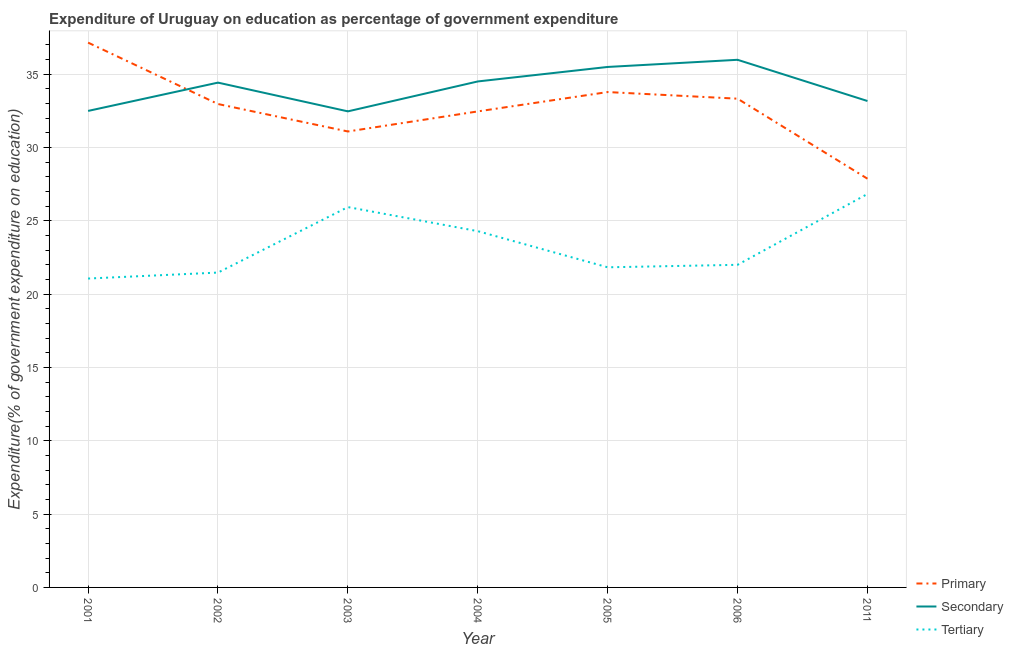How many different coloured lines are there?
Offer a very short reply. 3. Does the line corresponding to expenditure on primary education intersect with the line corresponding to expenditure on secondary education?
Provide a short and direct response. Yes. Is the number of lines equal to the number of legend labels?
Provide a short and direct response. Yes. What is the expenditure on tertiary education in 2002?
Keep it short and to the point. 21.47. Across all years, what is the maximum expenditure on secondary education?
Offer a very short reply. 35.98. Across all years, what is the minimum expenditure on tertiary education?
Your response must be concise. 21.07. In which year was the expenditure on secondary education minimum?
Keep it short and to the point. 2003. What is the total expenditure on secondary education in the graph?
Provide a short and direct response. 238.56. What is the difference between the expenditure on secondary education in 2002 and that in 2005?
Offer a very short reply. -1.07. What is the difference between the expenditure on tertiary education in 2004 and the expenditure on primary education in 2005?
Keep it short and to the point. -9.49. What is the average expenditure on primary education per year?
Offer a very short reply. 32.67. In the year 2003, what is the difference between the expenditure on tertiary education and expenditure on primary education?
Keep it short and to the point. -5.16. What is the ratio of the expenditure on tertiary education in 2004 to that in 2005?
Your answer should be compact. 1.11. Is the expenditure on primary education in 2003 less than that in 2004?
Provide a short and direct response. Yes. Is the difference between the expenditure on tertiary education in 2003 and 2006 greater than the difference between the expenditure on primary education in 2003 and 2006?
Give a very brief answer. Yes. What is the difference between the highest and the second highest expenditure on primary education?
Your answer should be very brief. 3.37. What is the difference between the highest and the lowest expenditure on tertiary education?
Give a very brief answer. 5.77. In how many years, is the expenditure on primary education greater than the average expenditure on primary education taken over all years?
Offer a terse response. 4. Is it the case that in every year, the sum of the expenditure on primary education and expenditure on secondary education is greater than the expenditure on tertiary education?
Ensure brevity in your answer.  Yes. Does the expenditure on primary education monotonically increase over the years?
Your answer should be very brief. No. Is the expenditure on secondary education strictly greater than the expenditure on tertiary education over the years?
Your answer should be compact. Yes. Is the expenditure on primary education strictly less than the expenditure on tertiary education over the years?
Make the answer very short. No. How many years are there in the graph?
Ensure brevity in your answer.  7. What is the difference between two consecutive major ticks on the Y-axis?
Make the answer very short. 5. Are the values on the major ticks of Y-axis written in scientific E-notation?
Offer a terse response. No. Where does the legend appear in the graph?
Provide a succinct answer. Bottom right. What is the title of the graph?
Offer a terse response. Expenditure of Uruguay on education as percentage of government expenditure. Does "Labor Market" appear as one of the legend labels in the graph?
Provide a succinct answer. No. What is the label or title of the X-axis?
Offer a terse response. Year. What is the label or title of the Y-axis?
Offer a terse response. Expenditure(% of government expenditure on education). What is the Expenditure(% of government expenditure on education) of Primary in 2001?
Ensure brevity in your answer.  37.16. What is the Expenditure(% of government expenditure on education) of Secondary in 2001?
Provide a short and direct response. 32.5. What is the Expenditure(% of government expenditure on education) of Tertiary in 2001?
Provide a succinct answer. 21.07. What is the Expenditure(% of government expenditure on education) of Primary in 2002?
Your response must be concise. 32.97. What is the Expenditure(% of government expenditure on education) of Secondary in 2002?
Offer a terse response. 34.43. What is the Expenditure(% of government expenditure on education) in Tertiary in 2002?
Ensure brevity in your answer.  21.47. What is the Expenditure(% of government expenditure on education) in Primary in 2003?
Offer a terse response. 31.1. What is the Expenditure(% of government expenditure on education) in Secondary in 2003?
Your answer should be very brief. 32.47. What is the Expenditure(% of government expenditure on education) in Tertiary in 2003?
Provide a short and direct response. 25.94. What is the Expenditure(% of government expenditure on education) in Primary in 2004?
Provide a succinct answer. 32.47. What is the Expenditure(% of government expenditure on education) in Secondary in 2004?
Your response must be concise. 34.51. What is the Expenditure(% of government expenditure on education) of Tertiary in 2004?
Make the answer very short. 24.3. What is the Expenditure(% of government expenditure on education) of Primary in 2005?
Make the answer very short. 33.78. What is the Expenditure(% of government expenditure on education) in Secondary in 2005?
Your answer should be very brief. 35.5. What is the Expenditure(% of government expenditure on education) in Tertiary in 2005?
Your answer should be very brief. 21.83. What is the Expenditure(% of government expenditure on education) in Primary in 2006?
Provide a short and direct response. 33.33. What is the Expenditure(% of government expenditure on education) in Secondary in 2006?
Provide a short and direct response. 35.98. What is the Expenditure(% of government expenditure on education) in Tertiary in 2006?
Ensure brevity in your answer.  22. What is the Expenditure(% of government expenditure on education) in Primary in 2011?
Offer a very short reply. 27.88. What is the Expenditure(% of government expenditure on education) in Secondary in 2011?
Offer a very short reply. 33.17. What is the Expenditure(% of government expenditure on education) in Tertiary in 2011?
Offer a terse response. 26.83. Across all years, what is the maximum Expenditure(% of government expenditure on education) in Primary?
Give a very brief answer. 37.16. Across all years, what is the maximum Expenditure(% of government expenditure on education) in Secondary?
Keep it short and to the point. 35.98. Across all years, what is the maximum Expenditure(% of government expenditure on education) in Tertiary?
Offer a terse response. 26.83. Across all years, what is the minimum Expenditure(% of government expenditure on education) of Primary?
Ensure brevity in your answer.  27.88. Across all years, what is the minimum Expenditure(% of government expenditure on education) in Secondary?
Your answer should be compact. 32.47. Across all years, what is the minimum Expenditure(% of government expenditure on education) in Tertiary?
Offer a terse response. 21.07. What is the total Expenditure(% of government expenditure on education) of Primary in the graph?
Ensure brevity in your answer.  228.68. What is the total Expenditure(% of government expenditure on education) of Secondary in the graph?
Your response must be concise. 238.56. What is the total Expenditure(% of government expenditure on education) of Tertiary in the graph?
Keep it short and to the point. 163.45. What is the difference between the Expenditure(% of government expenditure on education) of Primary in 2001 and that in 2002?
Keep it short and to the point. 4.19. What is the difference between the Expenditure(% of government expenditure on education) of Secondary in 2001 and that in 2002?
Your response must be concise. -1.93. What is the difference between the Expenditure(% of government expenditure on education) of Tertiary in 2001 and that in 2002?
Your response must be concise. -0.41. What is the difference between the Expenditure(% of government expenditure on education) in Primary in 2001 and that in 2003?
Your answer should be very brief. 6.06. What is the difference between the Expenditure(% of government expenditure on education) of Secondary in 2001 and that in 2003?
Your response must be concise. 0.03. What is the difference between the Expenditure(% of government expenditure on education) of Tertiary in 2001 and that in 2003?
Your answer should be compact. -4.87. What is the difference between the Expenditure(% of government expenditure on education) of Primary in 2001 and that in 2004?
Give a very brief answer. 4.69. What is the difference between the Expenditure(% of government expenditure on education) in Secondary in 2001 and that in 2004?
Your answer should be compact. -2.01. What is the difference between the Expenditure(% of government expenditure on education) of Tertiary in 2001 and that in 2004?
Ensure brevity in your answer.  -3.23. What is the difference between the Expenditure(% of government expenditure on education) of Primary in 2001 and that in 2005?
Your answer should be compact. 3.37. What is the difference between the Expenditure(% of government expenditure on education) of Secondary in 2001 and that in 2005?
Your answer should be compact. -3. What is the difference between the Expenditure(% of government expenditure on education) in Tertiary in 2001 and that in 2005?
Provide a succinct answer. -0.77. What is the difference between the Expenditure(% of government expenditure on education) of Primary in 2001 and that in 2006?
Offer a very short reply. 3.82. What is the difference between the Expenditure(% of government expenditure on education) in Secondary in 2001 and that in 2006?
Provide a short and direct response. -3.49. What is the difference between the Expenditure(% of government expenditure on education) of Tertiary in 2001 and that in 2006?
Your answer should be compact. -0.94. What is the difference between the Expenditure(% of government expenditure on education) of Primary in 2001 and that in 2011?
Provide a succinct answer. 9.28. What is the difference between the Expenditure(% of government expenditure on education) in Secondary in 2001 and that in 2011?
Make the answer very short. -0.68. What is the difference between the Expenditure(% of government expenditure on education) of Tertiary in 2001 and that in 2011?
Provide a short and direct response. -5.77. What is the difference between the Expenditure(% of government expenditure on education) in Primary in 2002 and that in 2003?
Offer a very short reply. 1.87. What is the difference between the Expenditure(% of government expenditure on education) in Secondary in 2002 and that in 2003?
Provide a succinct answer. 1.96. What is the difference between the Expenditure(% of government expenditure on education) in Tertiary in 2002 and that in 2003?
Provide a succinct answer. -4.47. What is the difference between the Expenditure(% of government expenditure on education) of Primary in 2002 and that in 2004?
Provide a succinct answer. 0.5. What is the difference between the Expenditure(% of government expenditure on education) in Secondary in 2002 and that in 2004?
Ensure brevity in your answer.  -0.08. What is the difference between the Expenditure(% of government expenditure on education) in Tertiary in 2002 and that in 2004?
Your answer should be compact. -2.82. What is the difference between the Expenditure(% of government expenditure on education) in Primary in 2002 and that in 2005?
Offer a terse response. -0.82. What is the difference between the Expenditure(% of government expenditure on education) in Secondary in 2002 and that in 2005?
Your answer should be very brief. -1.07. What is the difference between the Expenditure(% of government expenditure on education) of Tertiary in 2002 and that in 2005?
Give a very brief answer. -0.36. What is the difference between the Expenditure(% of government expenditure on education) in Primary in 2002 and that in 2006?
Provide a succinct answer. -0.36. What is the difference between the Expenditure(% of government expenditure on education) of Secondary in 2002 and that in 2006?
Provide a succinct answer. -1.56. What is the difference between the Expenditure(% of government expenditure on education) in Tertiary in 2002 and that in 2006?
Your response must be concise. -0.53. What is the difference between the Expenditure(% of government expenditure on education) in Primary in 2002 and that in 2011?
Make the answer very short. 5.09. What is the difference between the Expenditure(% of government expenditure on education) in Secondary in 2002 and that in 2011?
Offer a very short reply. 1.25. What is the difference between the Expenditure(% of government expenditure on education) in Tertiary in 2002 and that in 2011?
Offer a very short reply. -5.36. What is the difference between the Expenditure(% of government expenditure on education) in Primary in 2003 and that in 2004?
Provide a succinct answer. -1.37. What is the difference between the Expenditure(% of government expenditure on education) of Secondary in 2003 and that in 2004?
Keep it short and to the point. -2.04. What is the difference between the Expenditure(% of government expenditure on education) in Tertiary in 2003 and that in 2004?
Keep it short and to the point. 1.64. What is the difference between the Expenditure(% of government expenditure on education) of Primary in 2003 and that in 2005?
Offer a very short reply. -2.69. What is the difference between the Expenditure(% of government expenditure on education) of Secondary in 2003 and that in 2005?
Your answer should be very brief. -3.03. What is the difference between the Expenditure(% of government expenditure on education) of Tertiary in 2003 and that in 2005?
Your answer should be compact. 4.11. What is the difference between the Expenditure(% of government expenditure on education) in Primary in 2003 and that in 2006?
Keep it short and to the point. -2.24. What is the difference between the Expenditure(% of government expenditure on education) of Secondary in 2003 and that in 2006?
Offer a very short reply. -3.52. What is the difference between the Expenditure(% of government expenditure on education) in Tertiary in 2003 and that in 2006?
Provide a succinct answer. 3.94. What is the difference between the Expenditure(% of government expenditure on education) in Primary in 2003 and that in 2011?
Make the answer very short. 3.22. What is the difference between the Expenditure(% of government expenditure on education) in Secondary in 2003 and that in 2011?
Your answer should be very brief. -0.71. What is the difference between the Expenditure(% of government expenditure on education) in Tertiary in 2003 and that in 2011?
Provide a short and direct response. -0.89. What is the difference between the Expenditure(% of government expenditure on education) in Primary in 2004 and that in 2005?
Provide a short and direct response. -1.32. What is the difference between the Expenditure(% of government expenditure on education) in Secondary in 2004 and that in 2005?
Provide a succinct answer. -0.99. What is the difference between the Expenditure(% of government expenditure on education) of Tertiary in 2004 and that in 2005?
Your response must be concise. 2.47. What is the difference between the Expenditure(% of government expenditure on education) of Primary in 2004 and that in 2006?
Provide a short and direct response. -0.87. What is the difference between the Expenditure(% of government expenditure on education) in Secondary in 2004 and that in 2006?
Your response must be concise. -1.48. What is the difference between the Expenditure(% of government expenditure on education) in Tertiary in 2004 and that in 2006?
Give a very brief answer. 2.3. What is the difference between the Expenditure(% of government expenditure on education) in Primary in 2004 and that in 2011?
Your response must be concise. 4.59. What is the difference between the Expenditure(% of government expenditure on education) of Secondary in 2004 and that in 2011?
Your response must be concise. 1.33. What is the difference between the Expenditure(% of government expenditure on education) in Tertiary in 2004 and that in 2011?
Keep it short and to the point. -2.54. What is the difference between the Expenditure(% of government expenditure on education) in Primary in 2005 and that in 2006?
Your response must be concise. 0.45. What is the difference between the Expenditure(% of government expenditure on education) of Secondary in 2005 and that in 2006?
Your answer should be compact. -0.49. What is the difference between the Expenditure(% of government expenditure on education) in Tertiary in 2005 and that in 2006?
Keep it short and to the point. -0.17. What is the difference between the Expenditure(% of government expenditure on education) in Primary in 2005 and that in 2011?
Keep it short and to the point. 5.91. What is the difference between the Expenditure(% of government expenditure on education) of Secondary in 2005 and that in 2011?
Offer a very short reply. 2.32. What is the difference between the Expenditure(% of government expenditure on education) in Tertiary in 2005 and that in 2011?
Provide a succinct answer. -5. What is the difference between the Expenditure(% of government expenditure on education) of Primary in 2006 and that in 2011?
Your response must be concise. 5.46. What is the difference between the Expenditure(% of government expenditure on education) of Secondary in 2006 and that in 2011?
Your answer should be compact. 2.81. What is the difference between the Expenditure(% of government expenditure on education) in Tertiary in 2006 and that in 2011?
Offer a very short reply. -4.83. What is the difference between the Expenditure(% of government expenditure on education) of Primary in 2001 and the Expenditure(% of government expenditure on education) of Secondary in 2002?
Offer a terse response. 2.73. What is the difference between the Expenditure(% of government expenditure on education) of Primary in 2001 and the Expenditure(% of government expenditure on education) of Tertiary in 2002?
Your answer should be compact. 15.68. What is the difference between the Expenditure(% of government expenditure on education) of Secondary in 2001 and the Expenditure(% of government expenditure on education) of Tertiary in 2002?
Keep it short and to the point. 11.02. What is the difference between the Expenditure(% of government expenditure on education) of Primary in 2001 and the Expenditure(% of government expenditure on education) of Secondary in 2003?
Ensure brevity in your answer.  4.69. What is the difference between the Expenditure(% of government expenditure on education) in Primary in 2001 and the Expenditure(% of government expenditure on education) in Tertiary in 2003?
Provide a succinct answer. 11.22. What is the difference between the Expenditure(% of government expenditure on education) in Secondary in 2001 and the Expenditure(% of government expenditure on education) in Tertiary in 2003?
Provide a succinct answer. 6.56. What is the difference between the Expenditure(% of government expenditure on education) in Primary in 2001 and the Expenditure(% of government expenditure on education) in Secondary in 2004?
Your response must be concise. 2.65. What is the difference between the Expenditure(% of government expenditure on education) in Primary in 2001 and the Expenditure(% of government expenditure on education) in Tertiary in 2004?
Provide a short and direct response. 12.86. What is the difference between the Expenditure(% of government expenditure on education) in Secondary in 2001 and the Expenditure(% of government expenditure on education) in Tertiary in 2004?
Offer a terse response. 8.2. What is the difference between the Expenditure(% of government expenditure on education) in Primary in 2001 and the Expenditure(% of government expenditure on education) in Secondary in 2005?
Your response must be concise. 1.66. What is the difference between the Expenditure(% of government expenditure on education) in Primary in 2001 and the Expenditure(% of government expenditure on education) in Tertiary in 2005?
Provide a succinct answer. 15.32. What is the difference between the Expenditure(% of government expenditure on education) of Secondary in 2001 and the Expenditure(% of government expenditure on education) of Tertiary in 2005?
Your answer should be very brief. 10.67. What is the difference between the Expenditure(% of government expenditure on education) of Primary in 2001 and the Expenditure(% of government expenditure on education) of Secondary in 2006?
Offer a terse response. 1.17. What is the difference between the Expenditure(% of government expenditure on education) of Primary in 2001 and the Expenditure(% of government expenditure on education) of Tertiary in 2006?
Give a very brief answer. 15.15. What is the difference between the Expenditure(% of government expenditure on education) in Secondary in 2001 and the Expenditure(% of government expenditure on education) in Tertiary in 2006?
Give a very brief answer. 10.5. What is the difference between the Expenditure(% of government expenditure on education) in Primary in 2001 and the Expenditure(% of government expenditure on education) in Secondary in 2011?
Offer a terse response. 3.98. What is the difference between the Expenditure(% of government expenditure on education) of Primary in 2001 and the Expenditure(% of government expenditure on education) of Tertiary in 2011?
Offer a terse response. 10.32. What is the difference between the Expenditure(% of government expenditure on education) in Secondary in 2001 and the Expenditure(% of government expenditure on education) in Tertiary in 2011?
Give a very brief answer. 5.66. What is the difference between the Expenditure(% of government expenditure on education) in Primary in 2002 and the Expenditure(% of government expenditure on education) in Secondary in 2003?
Provide a succinct answer. 0.5. What is the difference between the Expenditure(% of government expenditure on education) in Primary in 2002 and the Expenditure(% of government expenditure on education) in Tertiary in 2003?
Make the answer very short. 7.03. What is the difference between the Expenditure(% of government expenditure on education) of Secondary in 2002 and the Expenditure(% of government expenditure on education) of Tertiary in 2003?
Your response must be concise. 8.49. What is the difference between the Expenditure(% of government expenditure on education) of Primary in 2002 and the Expenditure(% of government expenditure on education) of Secondary in 2004?
Offer a very short reply. -1.54. What is the difference between the Expenditure(% of government expenditure on education) of Primary in 2002 and the Expenditure(% of government expenditure on education) of Tertiary in 2004?
Offer a terse response. 8.67. What is the difference between the Expenditure(% of government expenditure on education) in Secondary in 2002 and the Expenditure(% of government expenditure on education) in Tertiary in 2004?
Offer a terse response. 10.13. What is the difference between the Expenditure(% of government expenditure on education) in Primary in 2002 and the Expenditure(% of government expenditure on education) in Secondary in 2005?
Provide a succinct answer. -2.53. What is the difference between the Expenditure(% of government expenditure on education) in Primary in 2002 and the Expenditure(% of government expenditure on education) in Tertiary in 2005?
Offer a terse response. 11.14. What is the difference between the Expenditure(% of government expenditure on education) of Secondary in 2002 and the Expenditure(% of government expenditure on education) of Tertiary in 2005?
Your answer should be compact. 12.6. What is the difference between the Expenditure(% of government expenditure on education) of Primary in 2002 and the Expenditure(% of government expenditure on education) of Secondary in 2006?
Provide a succinct answer. -3.02. What is the difference between the Expenditure(% of government expenditure on education) in Primary in 2002 and the Expenditure(% of government expenditure on education) in Tertiary in 2006?
Make the answer very short. 10.97. What is the difference between the Expenditure(% of government expenditure on education) of Secondary in 2002 and the Expenditure(% of government expenditure on education) of Tertiary in 2006?
Your answer should be compact. 12.43. What is the difference between the Expenditure(% of government expenditure on education) in Primary in 2002 and the Expenditure(% of government expenditure on education) in Secondary in 2011?
Make the answer very short. -0.21. What is the difference between the Expenditure(% of government expenditure on education) of Primary in 2002 and the Expenditure(% of government expenditure on education) of Tertiary in 2011?
Offer a very short reply. 6.14. What is the difference between the Expenditure(% of government expenditure on education) of Secondary in 2002 and the Expenditure(% of government expenditure on education) of Tertiary in 2011?
Give a very brief answer. 7.6. What is the difference between the Expenditure(% of government expenditure on education) of Primary in 2003 and the Expenditure(% of government expenditure on education) of Secondary in 2004?
Your response must be concise. -3.41. What is the difference between the Expenditure(% of government expenditure on education) of Primary in 2003 and the Expenditure(% of government expenditure on education) of Tertiary in 2004?
Your response must be concise. 6.8. What is the difference between the Expenditure(% of government expenditure on education) in Secondary in 2003 and the Expenditure(% of government expenditure on education) in Tertiary in 2004?
Ensure brevity in your answer.  8.17. What is the difference between the Expenditure(% of government expenditure on education) of Primary in 2003 and the Expenditure(% of government expenditure on education) of Secondary in 2005?
Provide a short and direct response. -4.4. What is the difference between the Expenditure(% of government expenditure on education) of Primary in 2003 and the Expenditure(% of government expenditure on education) of Tertiary in 2005?
Provide a short and direct response. 9.26. What is the difference between the Expenditure(% of government expenditure on education) in Secondary in 2003 and the Expenditure(% of government expenditure on education) in Tertiary in 2005?
Provide a short and direct response. 10.64. What is the difference between the Expenditure(% of government expenditure on education) in Primary in 2003 and the Expenditure(% of government expenditure on education) in Secondary in 2006?
Give a very brief answer. -4.89. What is the difference between the Expenditure(% of government expenditure on education) in Primary in 2003 and the Expenditure(% of government expenditure on education) in Tertiary in 2006?
Your answer should be very brief. 9.09. What is the difference between the Expenditure(% of government expenditure on education) in Secondary in 2003 and the Expenditure(% of government expenditure on education) in Tertiary in 2006?
Give a very brief answer. 10.47. What is the difference between the Expenditure(% of government expenditure on education) in Primary in 2003 and the Expenditure(% of government expenditure on education) in Secondary in 2011?
Offer a very short reply. -2.08. What is the difference between the Expenditure(% of government expenditure on education) of Primary in 2003 and the Expenditure(% of government expenditure on education) of Tertiary in 2011?
Offer a terse response. 4.26. What is the difference between the Expenditure(% of government expenditure on education) in Secondary in 2003 and the Expenditure(% of government expenditure on education) in Tertiary in 2011?
Offer a terse response. 5.63. What is the difference between the Expenditure(% of government expenditure on education) of Primary in 2004 and the Expenditure(% of government expenditure on education) of Secondary in 2005?
Offer a very short reply. -3.03. What is the difference between the Expenditure(% of government expenditure on education) in Primary in 2004 and the Expenditure(% of government expenditure on education) in Tertiary in 2005?
Keep it short and to the point. 10.63. What is the difference between the Expenditure(% of government expenditure on education) in Secondary in 2004 and the Expenditure(% of government expenditure on education) in Tertiary in 2005?
Provide a succinct answer. 12.68. What is the difference between the Expenditure(% of government expenditure on education) of Primary in 2004 and the Expenditure(% of government expenditure on education) of Secondary in 2006?
Give a very brief answer. -3.52. What is the difference between the Expenditure(% of government expenditure on education) in Primary in 2004 and the Expenditure(% of government expenditure on education) in Tertiary in 2006?
Provide a succinct answer. 10.46. What is the difference between the Expenditure(% of government expenditure on education) in Secondary in 2004 and the Expenditure(% of government expenditure on education) in Tertiary in 2006?
Provide a short and direct response. 12.51. What is the difference between the Expenditure(% of government expenditure on education) in Primary in 2004 and the Expenditure(% of government expenditure on education) in Secondary in 2011?
Offer a terse response. -0.71. What is the difference between the Expenditure(% of government expenditure on education) in Primary in 2004 and the Expenditure(% of government expenditure on education) in Tertiary in 2011?
Keep it short and to the point. 5.63. What is the difference between the Expenditure(% of government expenditure on education) in Secondary in 2004 and the Expenditure(% of government expenditure on education) in Tertiary in 2011?
Keep it short and to the point. 7.67. What is the difference between the Expenditure(% of government expenditure on education) in Primary in 2005 and the Expenditure(% of government expenditure on education) in Secondary in 2006?
Make the answer very short. -2.2. What is the difference between the Expenditure(% of government expenditure on education) in Primary in 2005 and the Expenditure(% of government expenditure on education) in Tertiary in 2006?
Your response must be concise. 11.78. What is the difference between the Expenditure(% of government expenditure on education) in Secondary in 2005 and the Expenditure(% of government expenditure on education) in Tertiary in 2006?
Your answer should be compact. 13.49. What is the difference between the Expenditure(% of government expenditure on education) in Primary in 2005 and the Expenditure(% of government expenditure on education) in Secondary in 2011?
Give a very brief answer. 0.61. What is the difference between the Expenditure(% of government expenditure on education) of Primary in 2005 and the Expenditure(% of government expenditure on education) of Tertiary in 2011?
Your response must be concise. 6.95. What is the difference between the Expenditure(% of government expenditure on education) in Secondary in 2005 and the Expenditure(% of government expenditure on education) in Tertiary in 2011?
Your answer should be compact. 8.66. What is the difference between the Expenditure(% of government expenditure on education) in Primary in 2006 and the Expenditure(% of government expenditure on education) in Secondary in 2011?
Provide a short and direct response. 0.16. What is the difference between the Expenditure(% of government expenditure on education) of Primary in 2006 and the Expenditure(% of government expenditure on education) of Tertiary in 2011?
Provide a succinct answer. 6.5. What is the difference between the Expenditure(% of government expenditure on education) of Secondary in 2006 and the Expenditure(% of government expenditure on education) of Tertiary in 2011?
Your answer should be compact. 9.15. What is the average Expenditure(% of government expenditure on education) of Primary per year?
Provide a short and direct response. 32.67. What is the average Expenditure(% of government expenditure on education) of Secondary per year?
Offer a very short reply. 34.08. What is the average Expenditure(% of government expenditure on education) in Tertiary per year?
Offer a very short reply. 23.35. In the year 2001, what is the difference between the Expenditure(% of government expenditure on education) of Primary and Expenditure(% of government expenditure on education) of Secondary?
Keep it short and to the point. 4.66. In the year 2001, what is the difference between the Expenditure(% of government expenditure on education) of Primary and Expenditure(% of government expenditure on education) of Tertiary?
Offer a very short reply. 16.09. In the year 2001, what is the difference between the Expenditure(% of government expenditure on education) of Secondary and Expenditure(% of government expenditure on education) of Tertiary?
Your answer should be very brief. 11.43. In the year 2002, what is the difference between the Expenditure(% of government expenditure on education) in Primary and Expenditure(% of government expenditure on education) in Secondary?
Keep it short and to the point. -1.46. In the year 2002, what is the difference between the Expenditure(% of government expenditure on education) of Primary and Expenditure(% of government expenditure on education) of Tertiary?
Offer a very short reply. 11.5. In the year 2002, what is the difference between the Expenditure(% of government expenditure on education) in Secondary and Expenditure(% of government expenditure on education) in Tertiary?
Keep it short and to the point. 12.96. In the year 2003, what is the difference between the Expenditure(% of government expenditure on education) of Primary and Expenditure(% of government expenditure on education) of Secondary?
Provide a succinct answer. -1.37. In the year 2003, what is the difference between the Expenditure(% of government expenditure on education) of Primary and Expenditure(% of government expenditure on education) of Tertiary?
Make the answer very short. 5.16. In the year 2003, what is the difference between the Expenditure(% of government expenditure on education) of Secondary and Expenditure(% of government expenditure on education) of Tertiary?
Your answer should be very brief. 6.53. In the year 2004, what is the difference between the Expenditure(% of government expenditure on education) of Primary and Expenditure(% of government expenditure on education) of Secondary?
Offer a terse response. -2.04. In the year 2004, what is the difference between the Expenditure(% of government expenditure on education) in Primary and Expenditure(% of government expenditure on education) in Tertiary?
Give a very brief answer. 8.17. In the year 2004, what is the difference between the Expenditure(% of government expenditure on education) of Secondary and Expenditure(% of government expenditure on education) of Tertiary?
Offer a terse response. 10.21. In the year 2005, what is the difference between the Expenditure(% of government expenditure on education) of Primary and Expenditure(% of government expenditure on education) of Secondary?
Your answer should be very brief. -1.71. In the year 2005, what is the difference between the Expenditure(% of government expenditure on education) in Primary and Expenditure(% of government expenditure on education) in Tertiary?
Offer a very short reply. 11.95. In the year 2005, what is the difference between the Expenditure(% of government expenditure on education) in Secondary and Expenditure(% of government expenditure on education) in Tertiary?
Your answer should be very brief. 13.66. In the year 2006, what is the difference between the Expenditure(% of government expenditure on education) of Primary and Expenditure(% of government expenditure on education) of Secondary?
Your response must be concise. -2.65. In the year 2006, what is the difference between the Expenditure(% of government expenditure on education) in Primary and Expenditure(% of government expenditure on education) in Tertiary?
Make the answer very short. 11.33. In the year 2006, what is the difference between the Expenditure(% of government expenditure on education) in Secondary and Expenditure(% of government expenditure on education) in Tertiary?
Keep it short and to the point. 13.98. In the year 2011, what is the difference between the Expenditure(% of government expenditure on education) of Primary and Expenditure(% of government expenditure on education) of Secondary?
Ensure brevity in your answer.  -5.3. In the year 2011, what is the difference between the Expenditure(% of government expenditure on education) of Primary and Expenditure(% of government expenditure on education) of Tertiary?
Make the answer very short. 1.04. In the year 2011, what is the difference between the Expenditure(% of government expenditure on education) of Secondary and Expenditure(% of government expenditure on education) of Tertiary?
Your answer should be very brief. 6.34. What is the ratio of the Expenditure(% of government expenditure on education) of Primary in 2001 to that in 2002?
Offer a terse response. 1.13. What is the ratio of the Expenditure(% of government expenditure on education) in Secondary in 2001 to that in 2002?
Offer a terse response. 0.94. What is the ratio of the Expenditure(% of government expenditure on education) of Primary in 2001 to that in 2003?
Your answer should be very brief. 1.19. What is the ratio of the Expenditure(% of government expenditure on education) in Secondary in 2001 to that in 2003?
Offer a very short reply. 1. What is the ratio of the Expenditure(% of government expenditure on education) in Tertiary in 2001 to that in 2003?
Your answer should be very brief. 0.81. What is the ratio of the Expenditure(% of government expenditure on education) in Primary in 2001 to that in 2004?
Provide a succinct answer. 1.14. What is the ratio of the Expenditure(% of government expenditure on education) in Secondary in 2001 to that in 2004?
Your answer should be compact. 0.94. What is the ratio of the Expenditure(% of government expenditure on education) of Tertiary in 2001 to that in 2004?
Your response must be concise. 0.87. What is the ratio of the Expenditure(% of government expenditure on education) in Primary in 2001 to that in 2005?
Your answer should be very brief. 1.1. What is the ratio of the Expenditure(% of government expenditure on education) of Secondary in 2001 to that in 2005?
Your answer should be very brief. 0.92. What is the ratio of the Expenditure(% of government expenditure on education) of Tertiary in 2001 to that in 2005?
Make the answer very short. 0.96. What is the ratio of the Expenditure(% of government expenditure on education) of Primary in 2001 to that in 2006?
Offer a terse response. 1.11. What is the ratio of the Expenditure(% of government expenditure on education) in Secondary in 2001 to that in 2006?
Keep it short and to the point. 0.9. What is the ratio of the Expenditure(% of government expenditure on education) in Tertiary in 2001 to that in 2006?
Your response must be concise. 0.96. What is the ratio of the Expenditure(% of government expenditure on education) in Primary in 2001 to that in 2011?
Provide a short and direct response. 1.33. What is the ratio of the Expenditure(% of government expenditure on education) in Secondary in 2001 to that in 2011?
Keep it short and to the point. 0.98. What is the ratio of the Expenditure(% of government expenditure on education) of Tertiary in 2001 to that in 2011?
Provide a succinct answer. 0.79. What is the ratio of the Expenditure(% of government expenditure on education) of Primary in 2002 to that in 2003?
Keep it short and to the point. 1.06. What is the ratio of the Expenditure(% of government expenditure on education) of Secondary in 2002 to that in 2003?
Your response must be concise. 1.06. What is the ratio of the Expenditure(% of government expenditure on education) of Tertiary in 2002 to that in 2003?
Ensure brevity in your answer.  0.83. What is the ratio of the Expenditure(% of government expenditure on education) in Primary in 2002 to that in 2004?
Your answer should be compact. 1.02. What is the ratio of the Expenditure(% of government expenditure on education) of Tertiary in 2002 to that in 2004?
Your answer should be very brief. 0.88. What is the ratio of the Expenditure(% of government expenditure on education) of Primary in 2002 to that in 2005?
Provide a succinct answer. 0.98. What is the ratio of the Expenditure(% of government expenditure on education) of Secondary in 2002 to that in 2005?
Your answer should be very brief. 0.97. What is the ratio of the Expenditure(% of government expenditure on education) of Tertiary in 2002 to that in 2005?
Provide a succinct answer. 0.98. What is the ratio of the Expenditure(% of government expenditure on education) of Secondary in 2002 to that in 2006?
Provide a succinct answer. 0.96. What is the ratio of the Expenditure(% of government expenditure on education) of Tertiary in 2002 to that in 2006?
Give a very brief answer. 0.98. What is the ratio of the Expenditure(% of government expenditure on education) of Primary in 2002 to that in 2011?
Your answer should be very brief. 1.18. What is the ratio of the Expenditure(% of government expenditure on education) of Secondary in 2002 to that in 2011?
Your response must be concise. 1.04. What is the ratio of the Expenditure(% of government expenditure on education) of Tertiary in 2002 to that in 2011?
Provide a short and direct response. 0.8. What is the ratio of the Expenditure(% of government expenditure on education) of Primary in 2003 to that in 2004?
Your answer should be compact. 0.96. What is the ratio of the Expenditure(% of government expenditure on education) in Secondary in 2003 to that in 2004?
Give a very brief answer. 0.94. What is the ratio of the Expenditure(% of government expenditure on education) of Tertiary in 2003 to that in 2004?
Offer a very short reply. 1.07. What is the ratio of the Expenditure(% of government expenditure on education) in Primary in 2003 to that in 2005?
Your response must be concise. 0.92. What is the ratio of the Expenditure(% of government expenditure on education) of Secondary in 2003 to that in 2005?
Make the answer very short. 0.91. What is the ratio of the Expenditure(% of government expenditure on education) in Tertiary in 2003 to that in 2005?
Offer a very short reply. 1.19. What is the ratio of the Expenditure(% of government expenditure on education) in Primary in 2003 to that in 2006?
Offer a terse response. 0.93. What is the ratio of the Expenditure(% of government expenditure on education) of Secondary in 2003 to that in 2006?
Ensure brevity in your answer.  0.9. What is the ratio of the Expenditure(% of government expenditure on education) in Tertiary in 2003 to that in 2006?
Offer a terse response. 1.18. What is the ratio of the Expenditure(% of government expenditure on education) of Primary in 2003 to that in 2011?
Provide a succinct answer. 1.12. What is the ratio of the Expenditure(% of government expenditure on education) of Secondary in 2003 to that in 2011?
Provide a short and direct response. 0.98. What is the ratio of the Expenditure(% of government expenditure on education) in Tertiary in 2003 to that in 2011?
Keep it short and to the point. 0.97. What is the ratio of the Expenditure(% of government expenditure on education) of Primary in 2004 to that in 2005?
Keep it short and to the point. 0.96. What is the ratio of the Expenditure(% of government expenditure on education) of Secondary in 2004 to that in 2005?
Offer a very short reply. 0.97. What is the ratio of the Expenditure(% of government expenditure on education) of Tertiary in 2004 to that in 2005?
Provide a succinct answer. 1.11. What is the ratio of the Expenditure(% of government expenditure on education) in Primary in 2004 to that in 2006?
Your answer should be very brief. 0.97. What is the ratio of the Expenditure(% of government expenditure on education) of Secondary in 2004 to that in 2006?
Provide a short and direct response. 0.96. What is the ratio of the Expenditure(% of government expenditure on education) in Tertiary in 2004 to that in 2006?
Your response must be concise. 1.1. What is the ratio of the Expenditure(% of government expenditure on education) of Primary in 2004 to that in 2011?
Give a very brief answer. 1.16. What is the ratio of the Expenditure(% of government expenditure on education) in Secondary in 2004 to that in 2011?
Your answer should be very brief. 1.04. What is the ratio of the Expenditure(% of government expenditure on education) in Tertiary in 2004 to that in 2011?
Offer a very short reply. 0.91. What is the ratio of the Expenditure(% of government expenditure on education) of Primary in 2005 to that in 2006?
Make the answer very short. 1.01. What is the ratio of the Expenditure(% of government expenditure on education) of Secondary in 2005 to that in 2006?
Ensure brevity in your answer.  0.99. What is the ratio of the Expenditure(% of government expenditure on education) of Primary in 2005 to that in 2011?
Offer a very short reply. 1.21. What is the ratio of the Expenditure(% of government expenditure on education) in Secondary in 2005 to that in 2011?
Provide a short and direct response. 1.07. What is the ratio of the Expenditure(% of government expenditure on education) in Tertiary in 2005 to that in 2011?
Your answer should be very brief. 0.81. What is the ratio of the Expenditure(% of government expenditure on education) in Primary in 2006 to that in 2011?
Give a very brief answer. 1.2. What is the ratio of the Expenditure(% of government expenditure on education) of Secondary in 2006 to that in 2011?
Provide a succinct answer. 1.08. What is the ratio of the Expenditure(% of government expenditure on education) in Tertiary in 2006 to that in 2011?
Make the answer very short. 0.82. What is the difference between the highest and the second highest Expenditure(% of government expenditure on education) in Primary?
Give a very brief answer. 3.37. What is the difference between the highest and the second highest Expenditure(% of government expenditure on education) in Secondary?
Offer a very short reply. 0.49. What is the difference between the highest and the second highest Expenditure(% of government expenditure on education) of Tertiary?
Provide a succinct answer. 0.89. What is the difference between the highest and the lowest Expenditure(% of government expenditure on education) in Primary?
Your response must be concise. 9.28. What is the difference between the highest and the lowest Expenditure(% of government expenditure on education) of Secondary?
Make the answer very short. 3.52. What is the difference between the highest and the lowest Expenditure(% of government expenditure on education) of Tertiary?
Offer a terse response. 5.77. 